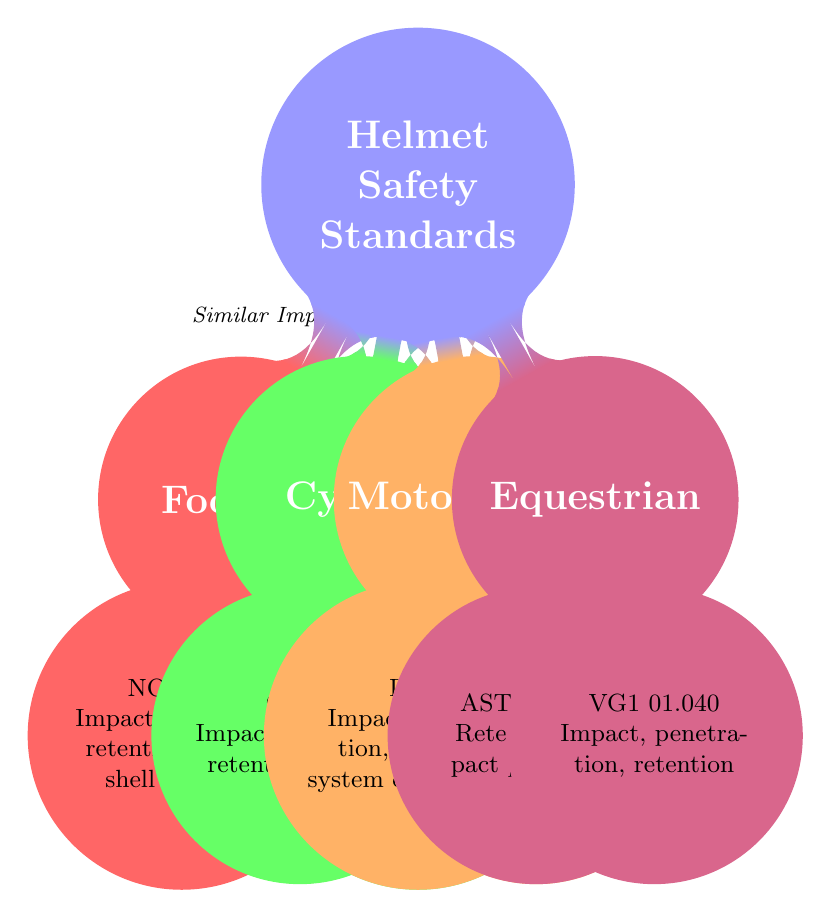What are the main associations for football helmet safety standards? The diagram lists NOCSAE as the main association responsible for football helmet safety standards. This information is represented in the node that branches off from the Football node.
Answer: NOCSAE How many sports are represented in the diagram? The diagram shows four sports: Football, Cycling, Motorcycling, and Equestrian. By counting the sport nodes, we confirm there are four entities listed.
Answer: 4 Which specification is shared between Motorcycling and Equestrian helmets? The diagram indicates that both sports include standards related to the retention system effectiveness, which is connected through the retention system standards label on the edges between the two sports.
Answer: Retention System Standards What type of impact tests are similar between Football and Cycling? According to the diagram, both sports utilize similar impact tests for helmet safety. This is highlighted in the labeled edge connecting the Football and Cycling sport nodes.
Answer: Similar Impact Tests Which safety standard is specific to Equestrian helmets? The diagram indicates that ASTM F1163 is a specific safety standard for Equestrian helmets, found in the node connected to the Equestrian sport.
Answer: ASTM F1163 What is the primary focus of CPSC standards in Cycling helmets? The diagram specifies that the CPSC standards for Cycling helmets focus on impact protection and retention system, which is denoted under the Cycling specification node.
Answer: Impact protection How do the shock absorption standards in Cycling compare to those in Motorcycling? The diagram shows that both sports include emphasis on shock absorption standards, indicating a similarity in this aspect of helmet safety across these two sports. This information is reflected in the connecting edge between the two sport nodes.
Answer: Impact Absorption Standards What is indicated regarding testing methods for Football helmets? The diagram details that testing methods for Football helmets include drop tests and impact tests at various velocities, represented in the specification nodes connected to the Football node.
Answer: Drop tests, impact tests at various velocities How does the Snell certification relate to Motorcycling helmets? The diagram shows that Snell provides standards focusing on thermal attenuation and penetration resistance, which are critical for the safety of Motorcycling helmets as indicated in the node for Motorcycling helmets' specifications.
Answer: Thermal attenuation, penetration resistance 